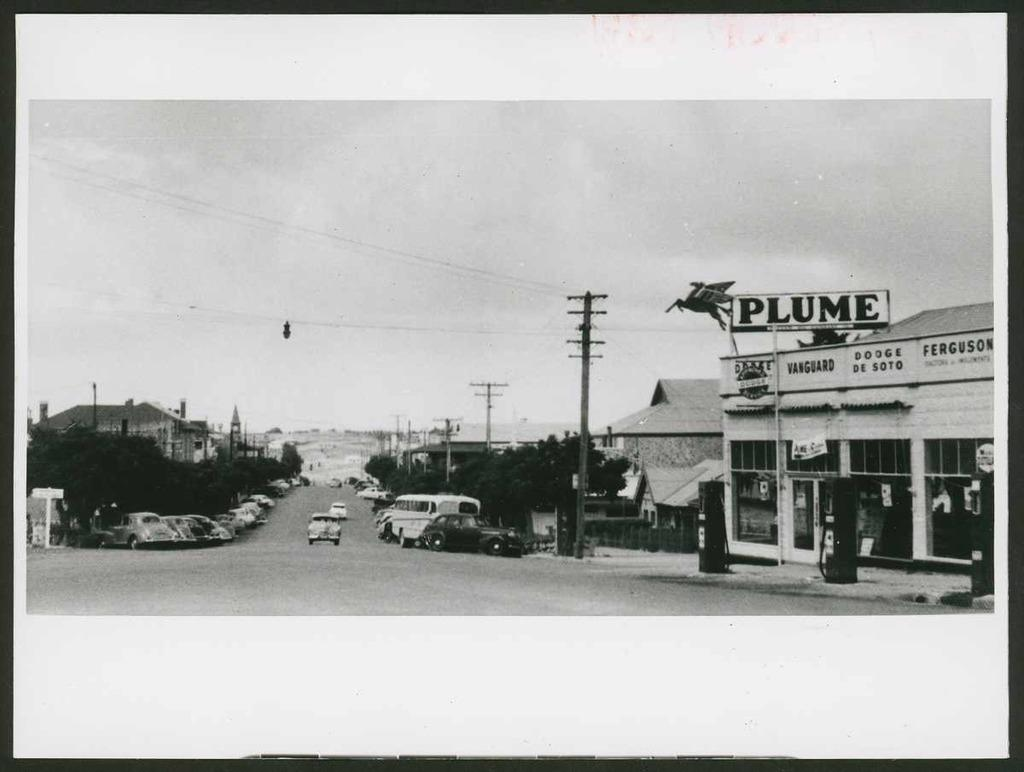<image>
Render a clear and concise summary of the photo. Black and white picture of cars parked outside a store named Plume. 